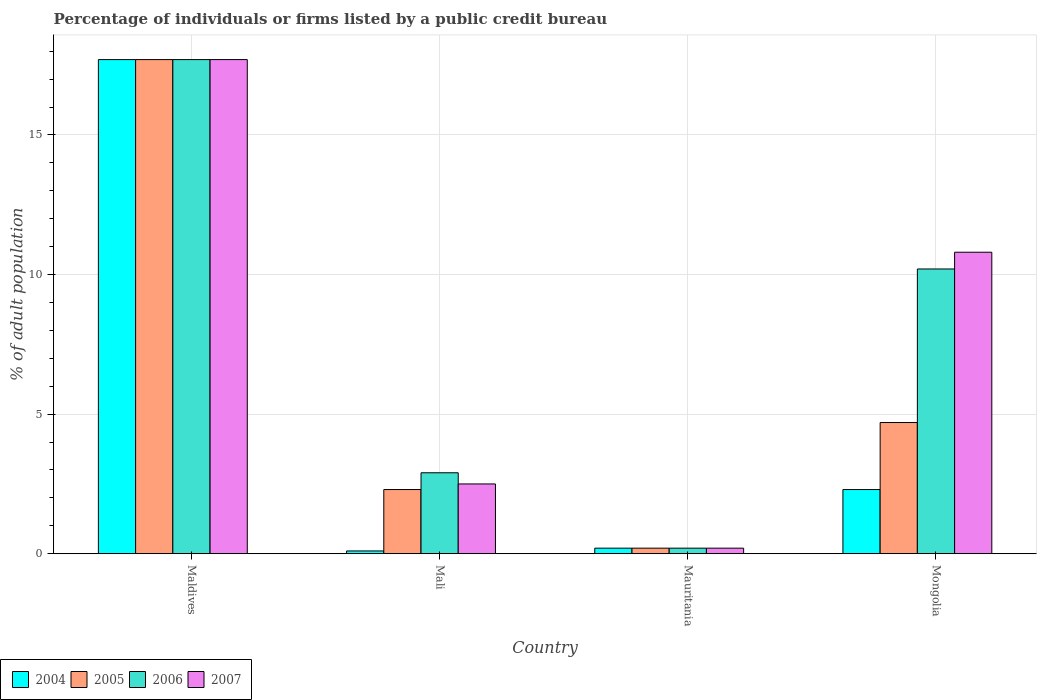How many different coloured bars are there?
Your answer should be compact. 4. Are the number of bars per tick equal to the number of legend labels?
Give a very brief answer. Yes. Are the number of bars on each tick of the X-axis equal?
Offer a very short reply. Yes. What is the label of the 3rd group of bars from the left?
Your answer should be very brief. Mauritania. In how many cases, is the number of bars for a given country not equal to the number of legend labels?
Ensure brevity in your answer.  0. In which country was the percentage of population listed by a public credit bureau in 2005 maximum?
Keep it short and to the point. Maldives. In which country was the percentage of population listed by a public credit bureau in 2006 minimum?
Keep it short and to the point. Mauritania. What is the total percentage of population listed by a public credit bureau in 2006 in the graph?
Provide a succinct answer. 31. What is the difference between the percentage of population listed by a public credit bureau in 2005 in Mali and that in Mauritania?
Offer a terse response. 2.1. What is the average percentage of population listed by a public credit bureau in 2004 per country?
Make the answer very short. 5.08. What is the difference between the percentage of population listed by a public credit bureau of/in 2004 and percentage of population listed by a public credit bureau of/in 2007 in Mongolia?
Ensure brevity in your answer.  -8.5. What is the ratio of the percentage of population listed by a public credit bureau in 2006 in Maldives to that in Mauritania?
Your answer should be compact. 88.5. Is the difference between the percentage of population listed by a public credit bureau in 2004 in Mali and Mongolia greater than the difference between the percentage of population listed by a public credit bureau in 2007 in Mali and Mongolia?
Give a very brief answer. Yes. What is the difference between the highest and the second highest percentage of population listed by a public credit bureau in 2005?
Keep it short and to the point. 15.4. In how many countries, is the percentage of population listed by a public credit bureau in 2007 greater than the average percentage of population listed by a public credit bureau in 2007 taken over all countries?
Your answer should be very brief. 2. Is the sum of the percentage of population listed by a public credit bureau in 2004 in Maldives and Mongolia greater than the maximum percentage of population listed by a public credit bureau in 2005 across all countries?
Ensure brevity in your answer.  Yes. What does the 2nd bar from the left in Mongolia represents?
Provide a succinct answer. 2005. What does the 1st bar from the right in Mali represents?
Provide a short and direct response. 2007. Are all the bars in the graph horizontal?
Offer a very short reply. No. Are the values on the major ticks of Y-axis written in scientific E-notation?
Offer a terse response. No. Does the graph contain any zero values?
Your answer should be compact. No. Does the graph contain grids?
Offer a terse response. Yes. Where does the legend appear in the graph?
Your answer should be very brief. Bottom left. What is the title of the graph?
Keep it short and to the point. Percentage of individuals or firms listed by a public credit bureau. What is the label or title of the Y-axis?
Offer a very short reply. % of adult population. What is the % of adult population in 2005 in Maldives?
Give a very brief answer. 17.7. What is the % of adult population of 2007 in Maldives?
Provide a short and direct response. 17.7. What is the % of adult population of 2004 in Mali?
Your answer should be very brief. 0.1. What is the % of adult population in 2005 in Mali?
Ensure brevity in your answer.  2.3. What is the % of adult population of 2006 in Mali?
Give a very brief answer. 2.9. What is the % of adult population of 2007 in Mali?
Your response must be concise. 2.5. What is the % of adult population in 2004 in Mauritania?
Your answer should be compact. 0.2. What is the % of adult population of 2005 in Mauritania?
Make the answer very short. 0.2. What is the % of adult population in 2007 in Mauritania?
Your answer should be very brief. 0.2. What is the % of adult population in 2004 in Mongolia?
Your response must be concise. 2.3. What is the % of adult population in 2005 in Mongolia?
Offer a very short reply. 4.7. What is the % of adult population in 2007 in Mongolia?
Make the answer very short. 10.8. Across all countries, what is the maximum % of adult population of 2004?
Your answer should be very brief. 17.7. Across all countries, what is the maximum % of adult population of 2007?
Keep it short and to the point. 17.7. Across all countries, what is the minimum % of adult population in 2005?
Make the answer very short. 0.2. Across all countries, what is the minimum % of adult population of 2006?
Your answer should be compact. 0.2. What is the total % of adult population of 2004 in the graph?
Your answer should be compact. 20.3. What is the total % of adult population in 2005 in the graph?
Offer a terse response. 24.9. What is the total % of adult population in 2006 in the graph?
Provide a short and direct response. 31. What is the total % of adult population in 2007 in the graph?
Your answer should be very brief. 31.2. What is the difference between the % of adult population in 2005 in Maldives and that in Mauritania?
Your answer should be very brief. 17.5. What is the difference between the % of adult population of 2007 in Maldives and that in Mauritania?
Give a very brief answer. 17.5. What is the difference between the % of adult population of 2006 in Maldives and that in Mongolia?
Make the answer very short. 7.5. What is the difference between the % of adult population in 2007 in Maldives and that in Mongolia?
Offer a terse response. 6.9. What is the difference between the % of adult population of 2004 in Mali and that in Mauritania?
Your answer should be very brief. -0.1. What is the difference between the % of adult population in 2005 in Mali and that in Mauritania?
Offer a very short reply. 2.1. What is the difference between the % of adult population in 2007 in Mali and that in Mauritania?
Keep it short and to the point. 2.3. What is the difference between the % of adult population in 2004 in Mali and that in Mongolia?
Offer a terse response. -2.2. What is the difference between the % of adult population in 2005 in Mali and that in Mongolia?
Provide a succinct answer. -2.4. What is the difference between the % of adult population in 2005 in Mauritania and that in Mongolia?
Provide a short and direct response. -4.5. What is the difference between the % of adult population in 2006 in Mauritania and that in Mongolia?
Offer a terse response. -10. What is the difference between the % of adult population of 2004 in Maldives and the % of adult population of 2005 in Mali?
Offer a very short reply. 15.4. What is the difference between the % of adult population in 2005 in Maldives and the % of adult population in 2006 in Mali?
Offer a very short reply. 14.8. What is the difference between the % of adult population of 2006 in Maldives and the % of adult population of 2007 in Mali?
Your answer should be very brief. 15.2. What is the difference between the % of adult population of 2004 in Maldives and the % of adult population of 2006 in Mauritania?
Offer a terse response. 17.5. What is the difference between the % of adult population of 2004 in Maldives and the % of adult population of 2007 in Mauritania?
Your response must be concise. 17.5. What is the difference between the % of adult population in 2005 in Maldives and the % of adult population in 2006 in Mauritania?
Provide a short and direct response. 17.5. What is the difference between the % of adult population of 2005 in Maldives and the % of adult population of 2007 in Mauritania?
Provide a succinct answer. 17.5. What is the difference between the % of adult population of 2004 in Maldives and the % of adult population of 2006 in Mongolia?
Offer a very short reply. 7.5. What is the difference between the % of adult population in 2004 in Maldives and the % of adult population in 2007 in Mongolia?
Provide a short and direct response. 6.9. What is the difference between the % of adult population in 2005 in Maldives and the % of adult population in 2006 in Mongolia?
Keep it short and to the point. 7.5. What is the difference between the % of adult population in 2005 in Maldives and the % of adult population in 2007 in Mongolia?
Offer a very short reply. 6.9. What is the difference between the % of adult population of 2006 in Maldives and the % of adult population of 2007 in Mongolia?
Your response must be concise. 6.9. What is the difference between the % of adult population in 2004 in Mali and the % of adult population in 2005 in Mauritania?
Keep it short and to the point. -0.1. What is the difference between the % of adult population in 2005 in Mali and the % of adult population in 2006 in Mauritania?
Offer a very short reply. 2.1. What is the difference between the % of adult population in 2005 in Mali and the % of adult population in 2007 in Mauritania?
Offer a terse response. 2.1. What is the difference between the % of adult population of 2004 in Mali and the % of adult population of 2006 in Mongolia?
Your response must be concise. -10.1. What is the difference between the % of adult population in 2004 in Mali and the % of adult population in 2007 in Mongolia?
Offer a terse response. -10.7. What is the difference between the % of adult population in 2005 in Mali and the % of adult population in 2006 in Mongolia?
Ensure brevity in your answer.  -7.9. What is the difference between the % of adult population in 2006 in Mali and the % of adult population in 2007 in Mongolia?
Your answer should be very brief. -7.9. What is the difference between the % of adult population in 2004 in Mauritania and the % of adult population in 2005 in Mongolia?
Make the answer very short. -4.5. What is the difference between the % of adult population of 2004 in Mauritania and the % of adult population of 2006 in Mongolia?
Ensure brevity in your answer.  -10. What is the difference between the % of adult population of 2005 in Mauritania and the % of adult population of 2007 in Mongolia?
Provide a succinct answer. -10.6. What is the difference between the % of adult population of 2006 in Mauritania and the % of adult population of 2007 in Mongolia?
Offer a terse response. -10.6. What is the average % of adult population of 2004 per country?
Ensure brevity in your answer.  5.08. What is the average % of adult population of 2005 per country?
Provide a short and direct response. 6.22. What is the average % of adult population of 2006 per country?
Offer a very short reply. 7.75. What is the difference between the % of adult population of 2004 and % of adult population of 2005 in Maldives?
Your response must be concise. 0. What is the difference between the % of adult population of 2004 and % of adult population of 2006 in Maldives?
Your response must be concise. 0. What is the difference between the % of adult population of 2004 and % of adult population of 2007 in Maldives?
Offer a very short reply. 0. What is the difference between the % of adult population in 2004 and % of adult population in 2006 in Mali?
Make the answer very short. -2.8. What is the difference between the % of adult population in 2004 and % of adult population in 2007 in Mali?
Your answer should be compact. -2.4. What is the difference between the % of adult population of 2005 and % of adult population of 2006 in Mali?
Keep it short and to the point. -0.6. What is the difference between the % of adult population in 2004 and % of adult population in 2007 in Mauritania?
Your response must be concise. 0. What is the difference between the % of adult population in 2005 and % of adult population in 2006 in Mauritania?
Your answer should be very brief. 0. What is the difference between the % of adult population in 2005 and % of adult population in 2007 in Mauritania?
Provide a succinct answer. 0. What is the difference between the % of adult population in 2005 and % of adult population in 2006 in Mongolia?
Provide a succinct answer. -5.5. What is the difference between the % of adult population of 2005 and % of adult population of 2007 in Mongolia?
Your answer should be compact. -6.1. What is the ratio of the % of adult population of 2004 in Maldives to that in Mali?
Your answer should be very brief. 177. What is the ratio of the % of adult population in 2005 in Maldives to that in Mali?
Your answer should be very brief. 7.7. What is the ratio of the % of adult population of 2006 in Maldives to that in Mali?
Make the answer very short. 6.1. What is the ratio of the % of adult population in 2007 in Maldives to that in Mali?
Provide a short and direct response. 7.08. What is the ratio of the % of adult population of 2004 in Maldives to that in Mauritania?
Ensure brevity in your answer.  88.5. What is the ratio of the % of adult population of 2005 in Maldives to that in Mauritania?
Provide a succinct answer. 88.5. What is the ratio of the % of adult population in 2006 in Maldives to that in Mauritania?
Give a very brief answer. 88.5. What is the ratio of the % of adult population in 2007 in Maldives to that in Mauritania?
Your answer should be compact. 88.5. What is the ratio of the % of adult population of 2004 in Maldives to that in Mongolia?
Give a very brief answer. 7.7. What is the ratio of the % of adult population of 2005 in Maldives to that in Mongolia?
Your answer should be compact. 3.77. What is the ratio of the % of adult population in 2006 in Maldives to that in Mongolia?
Offer a terse response. 1.74. What is the ratio of the % of adult population of 2007 in Maldives to that in Mongolia?
Provide a short and direct response. 1.64. What is the ratio of the % of adult population of 2005 in Mali to that in Mauritania?
Make the answer very short. 11.5. What is the ratio of the % of adult population of 2007 in Mali to that in Mauritania?
Provide a succinct answer. 12.5. What is the ratio of the % of adult population of 2004 in Mali to that in Mongolia?
Your answer should be very brief. 0.04. What is the ratio of the % of adult population in 2005 in Mali to that in Mongolia?
Offer a very short reply. 0.49. What is the ratio of the % of adult population of 2006 in Mali to that in Mongolia?
Provide a succinct answer. 0.28. What is the ratio of the % of adult population in 2007 in Mali to that in Mongolia?
Keep it short and to the point. 0.23. What is the ratio of the % of adult population in 2004 in Mauritania to that in Mongolia?
Your answer should be compact. 0.09. What is the ratio of the % of adult population in 2005 in Mauritania to that in Mongolia?
Your answer should be compact. 0.04. What is the ratio of the % of adult population in 2006 in Mauritania to that in Mongolia?
Make the answer very short. 0.02. What is the ratio of the % of adult population of 2007 in Mauritania to that in Mongolia?
Make the answer very short. 0.02. What is the difference between the highest and the second highest % of adult population of 2004?
Give a very brief answer. 15.4. What is the difference between the highest and the second highest % of adult population of 2005?
Offer a terse response. 13. What is the difference between the highest and the second highest % of adult population in 2006?
Your response must be concise. 7.5. What is the difference between the highest and the second highest % of adult population of 2007?
Your response must be concise. 6.9. What is the difference between the highest and the lowest % of adult population in 2004?
Your answer should be compact. 17.6. What is the difference between the highest and the lowest % of adult population of 2006?
Give a very brief answer. 17.5. What is the difference between the highest and the lowest % of adult population of 2007?
Provide a succinct answer. 17.5. 